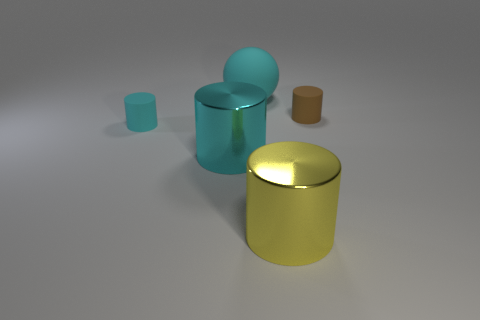How many objects have the same color as the matte ball?
Keep it short and to the point. 2. What number of small things are either brown rubber cylinders or shiny objects?
Your response must be concise. 1. There is a metallic cylinder that is the same color as the large ball; what is its size?
Give a very brief answer. Large. Are there any things that have the same material as the large sphere?
Your answer should be compact. Yes. There is a cylinder right of the big yellow thing; what is it made of?
Provide a short and direct response. Rubber. There is a rubber cylinder that is to the left of the large cyan rubber object; is its color the same as the large object that is behind the big cyan shiny cylinder?
Ensure brevity in your answer.  Yes. What color is the shiny cylinder that is the same size as the yellow thing?
Give a very brief answer. Cyan. What number of other objects are there of the same shape as the tiny brown matte object?
Make the answer very short. 3. How big is the rubber object that is to the right of the large sphere?
Give a very brief answer. Small. There is a tiny cyan rubber cylinder that is in front of the big rubber sphere; how many cyan balls are right of it?
Provide a short and direct response. 1. 